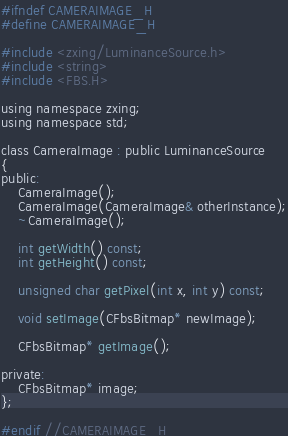<code> <loc_0><loc_0><loc_500><loc_500><_C_>#ifndef CAMERAIMAGE_H
#define CAMERAIMAGE_H

#include <zxing/LuminanceSource.h>
#include <string>
#include <FBS.H>  

using namespace zxing;
using namespace std;

class CameraImage : public LuminanceSource
{
public:
    CameraImage();
    CameraImage(CameraImage& otherInstance);
    ~CameraImage();
    
    int getWidth() const;
    int getHeight() const;
    
    unsigned char getPixel(int x, int y) const;
    
    void setImage(CFbsBitmap* newImage);
    
    CFbsBitmap* getImage();
  
private:
    CFbsBitmap* image;
};

#endif //CAMERAIMAGE_H
</code> 